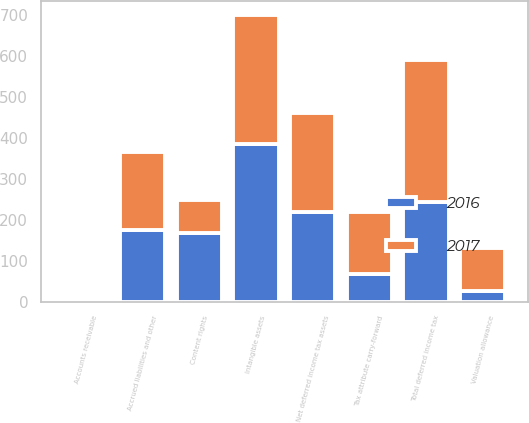<chart> <loc_0><loc_0><loc_500><loc_500><stacked_bar_chart><ecel><fcel>Accounts receivable<fcel>Tax attribute carry-forward<fcel>Accrued liabilities and other<fcel>Total deferred income tax<fcel>Valuation allowance<fcel>Net deferred income tax assets<fcel>Intangible assets<fcel>Content rights<nl><fcel>2017<fcel>5<fcel>151<fcel>190<fcel>346<fcel>105<fcel>241<fcel>315<fcel>82<nl><fcel>2016<fcel>2<fcel>67<fcel>174<fcel>243<fcel>25<fcel>218<fcel>384<fcel>166<nl></chart> 